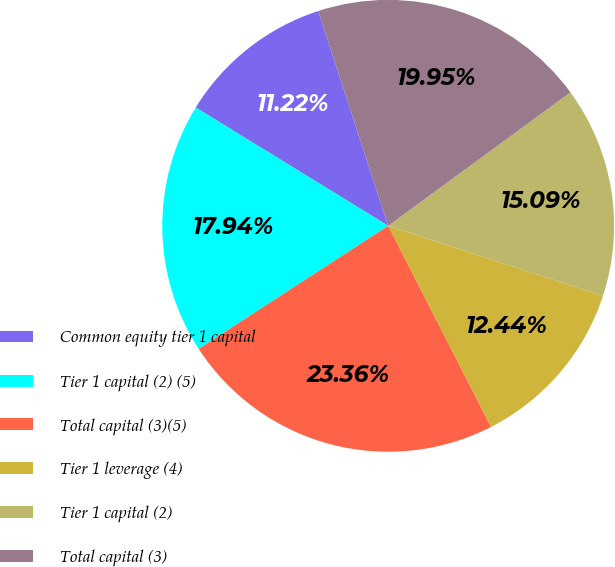<chart> <loc_0><loc_0><loc_500><loc_500><pie_chart><fcel>Common equity tier 1 capital<fcel>Tier 1 capital (2) (5)<fcel>Total capital (3)(5)<fcel>Tier 1 leverage (4)<fcel>Tier 1 capital (2)<fcel>Total capital (3)<nl><fcel>11.22%<fcel>17.94%<fcel>23.36%<fcel>12.44%<fcel>15.09%<fcel>19.95%<nl></chart> 